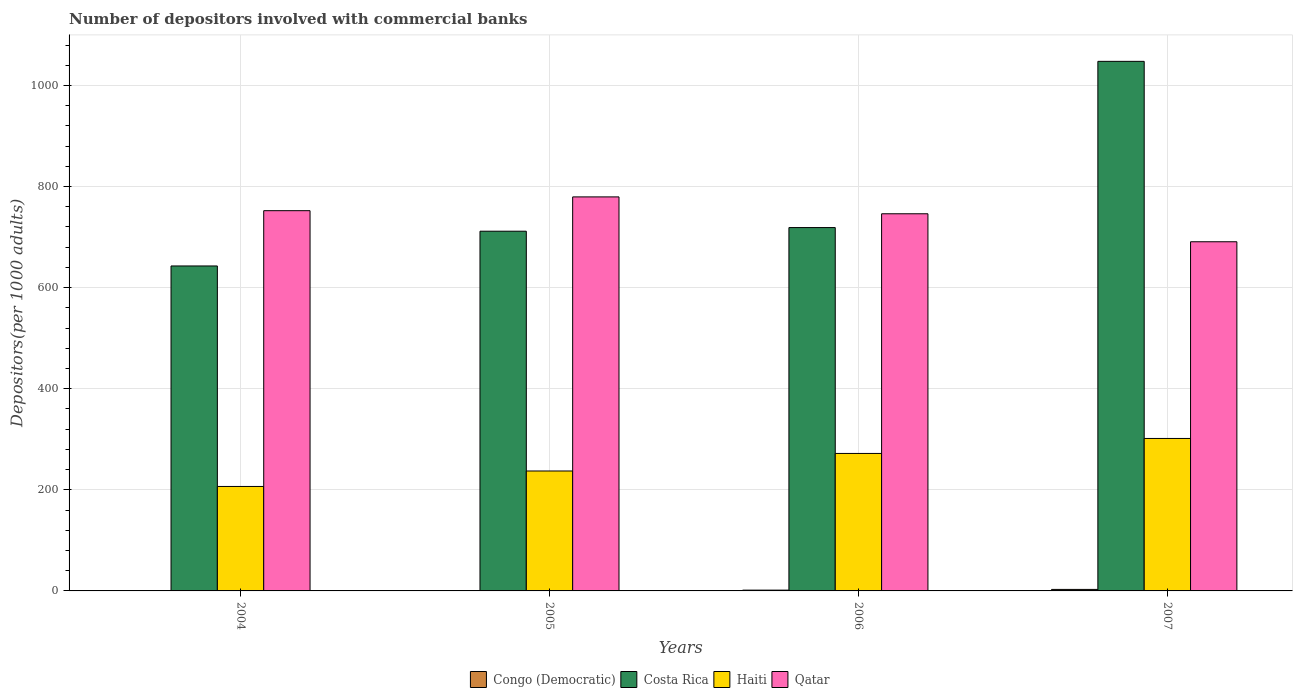How many bars are there on the 3rd tick from the left?
Offer a very short reply. 4. How many bars are there on the 3rd tick from the right?
Offer a very short reply. 4. What is the label of the 1st group of bars from the left?
Your answer should be very brief. 2004. In how many cases, is the number of bars for a given year not equal to the number of legend labels?
Keep it short and to the point. 0. What is the number of depositors involved with commercial banks in Qatar in 2005?
Your answer should be very brief. 779.56. Across all years, what is the maximum number of depositors involved with commercial banks in Qatar?
Provide a short and direct response. 779.56. Across all years, what is the minimum number of depositors involved with commercial banks in Qatar?
Offer a very short reply. 690.79. In which year was the number of depositors involved with commercial banks in Haiti minimum?
Offer a terse response. 2004. What is the total number of depositors involved with commercial banks in Haiti in the graph?
Make the answer very short. 1017.57. What is the difference between the number of depositors involved with commercial banks in Qatar in 2004 and that in 2005?
Make the answer very short. -27.27. What is the difference between the number of depositors involved with commercial banks in Congo (Democratic) in 2006 and the number of depositors involved with commercial banks in Haiti in 2004?
Ensure brevity in your answer.  -205.11. What is the average number of depositors involved with commercial banks in Costa Rica per year?
Make the answer very short. 780.3. In the year 2007, what is the difference between the number of depositors involved with commercial banks in Congo (Democratic) and number of depositors involved with commercial banks in Qatar?
Your response must be concise. -687.82. In how many years, is the number of depositors involved with commercial banks in Costa Rica greater than 200?
Keep it short and to the point. 4. What is the ratio of the number of depositors involved with commercial banks in Congo (Democratic) in 2005 to that in 2006?
Your answer should be compact. 0.51. What is the difference between the highest and the second highest number of depositors involved with commercial banks in Qatar?
Your response must be concise. 27.27. What is the difference between the highest and the lowest number of depositors involved with commercial banks in Costa Rica?
Provide a short and direct response. 404.79. In how many years, is the number of depositors involved with commercial banks in Qatar greater than the average number of depositors involved with commercial banks in Qatar taken over all years?
Offer a terse response. 3. Is the sum of the number of depositors involved with commercial banks in Congo (Democratic) in 2005 and 2007 greater than the maximum number of depositors involved with commercial banks in Qatar across all years?
Provide a succinct answer. No. Is it the case that in every year, the sum of the number of depositors involved with commercial banks in Haiti and number of depositors involved with commercial banks in Congo (Democratic) is greater than the sum of number of depositors involved with commercial banks in Qatar and number of depositors involved with commercial banks in Costa Rica?
Your response must be concise. No. What does the 3rd bar from the left in 2004 represents?
Give a very brief answer. Haiti. What does the 1st bar from the right in 2004 represents?
Make the answer very short. Qatar. How many bars are there?
Your answer should be compact. 16. What is the difference between two consecutive major ticks on the Y-axis?
Keep it short and to the point. 200. Are the values on the major ticks of Y-axis written in scientific E-notation?
Make the answer very short. No. Does the graph contain any zero values?
Provide a short and direct response. No. Where does the legend appear in the graph?
Provide a succinct answer. Bottom center. How many legend labels are there?
Ensure brevity in your answer.  4. What is the title of the graph?
Provide a succinct answer. Number of depositors involved with commercial banks. What is the label or title of the Y-axis?
Offer a terse response. Depositors(per 1000 adults). What is the Depositors(per 1000 adults) in Congo (Democratic) in 2004?
Ensure brevity in your answer.  0.48. What is the Depositors(per 1000 adults) of Costa Rica in 2004?
Offer a very short reply. 642.93. What is the Depositors(per 1000 adults) of Haiti in 2004?
Give a very brief answer. 206.67. What is the Depositors(per 1000 adults) of Qatar in 2004?
Keep it short and to the point. 752.28. What is the Depositors(per 1000 adults) of Congo (Democratic) in 2005?
Offer a very short reply. 0.8. What is the Depositors(per 1000 adults) in Costa Rica in 2005?
Your answer should be very brief. 711.68. What is the Depositors(per 1000 adults) of Haiti in 2005?
Ensure brevity in your answer.  237.27. What is the Depositors(per 1000 adults) of Qatar in 2005?
Your answer should be very brief. 779.56. What is the Depositors(per 1000 adults) of Congo (Democratic) in 2006?
Keep it short and to the point. 1.56. What is the Depositors(per 1000 adults) in Costa Rica in 2006?
Your answer should be compact. 718.87. What is the Depositors(per 1000 adults) of Haiti in 2006?
Offer a terse response. 271.98. What is the Depositors(per 1000 adults) of Qatar in 2006?
Your answer should be very brief. 746.16. What is the Depositors(per 1000 adults) in Congo (Democratic) in 2007?
Offer a terse response. 2.98. What is the Depositors(per 1000 adults) in Costa Rica in 2007?
Provide a short and direct response. 1047.71. What is the Depositors(per 1000 adults) in Haiti in 2007?
Offer a very short reply. 301.64. What is the Depositors(per 1000 adults) in Qatar in 2007?
Provide a short and direct response. 690.79. Across all years, what is the maximum Depositors(per 1000 adults) of Congo (Democratic)?
Give a very brief answer. 2.98. Across all years, what is the maximum Depositors(per 1000 adults) of Costa Rica?
Make the answer very short. 1047.71. Across all years, what is the maximum Depositors(per 1000 adults) in Haiti?
Your answer should be very brief. 301.64. Across all years, what is the maximum Depositors(per 1000 adults) in Qatar?
Give a very brief answer. 779.56. Across all years, what is the minimum Depositors(per 1000 adults) in Congo (Democratic)?
Provide a succinct answer. 0.48. Across all years, what is the minimum Depositors(per 1000 adults) in Costa Rica?
Ensure brevity in your answer.  642.93. Across all years, what is the minimum Depositors(per 1000 adults) of Haiti?
Your answer should be compact. 206.67. Across all years, what is the minimum Depositors(per 1000 adults) of Qatar?
Ensure brevity in your answer.  690.79. What is the total Depositors(per 1000 adults) in Congo (Democratic) in the graph?
Give a very brief answer. 5.83. What is the total Depositors(per 1000 adults) of Costa Rica in the graph?
Give a very brief answer. 3121.18. What is the total Depositors(per 1000 adults) of Haiti in the graph?
Ensure brevity in your answer.  1017.57. What is the total Depositors(per 1000 adults) in Qatar in the graph?
Your answer should be very brief. 2968.8. What is the difference between the Depositors(per 1000 adults) of Congo (Democratic) in 2004 and that in 2005?
Provide a succinct answer. -0.32. What is the difference between the Depositors(per 1000 adults) in Costa Rica in 2004 and that in 2005?
Your answer should be compact. -68.75. What is the difference between the Depositors(per 1000 adults) of Haiti in 2004 and that in 2005?
Provide a succinct answer. -30.6. What is the difference between the Depositors(per 1000 adults) in Qatar in 2004 and that in 2005?
Offer a terse response. -27.27. What is the difference between the Depositors(per 1000 adults) in Congo (Democratic) in 2004 and that in 2006?
Your answer should be very brief. -1.08. What is the difference between the Depositors(per 1000 adults) of Costa Rica in 2004 and that in 2006?
Keep it short and to the point. -75.94. What is the difference between the Depositors(per 1000 adults) in Haiti in 2004 and that in 2006?
Your response must be concise. -65.31. What is the difference between the Depositors(per 1000 adults) of Qatar in 2004 and that in 2006?
Offer a terse response. 6.12. What is the difference between the Depositors(per 1000 adults) in Congo (Democratic) in 2004 and that in 2007?
Offer a terse response. -2.5. What is the difference between the Depositors(per 1000 adults) of Costa Rica in 2004 and that in 2007?
Your answer should be compact. -404.79. What is the difference between the Depositors(per 1000 adults) of Haiti in 2004 and that in 2007?
Ensure brevity in your answer.  -94.97. What is the difference between the Depositors(per 1000 adults) of Qatar in 2004 and that in 2007?
Offer a very short reply. 61.49. What is the difference between the Depositors(per 1000 adults) of Congo (Democratic) in 2005 and that in 2006?
Give a very brief answer. -0.76. What is the difference between the Depositors(per 1000 adults) of Costa Rica in 2005 and that in 2006?
Your response must be concise. -7.19. What is the difference between the Depositors(per 1000 adults) of Haiti in 2005 and that in 2006?
Your answer should be very brief. -34.71. What is the difference between the Depositors(per 1000 adults) in Qatar in 2005 and that in 2006?
Offer a very short reply. 33.4. What is the difference between the Depositors(per 1000 adults) in Congo (Democratic) in 2005 and that in 2007?
Offer a very short reply. -2.18. What is the difference between the Depositors(per 1000 adults) of Costa Rica in 2005 and that in 2007?
Give a very brief answer. -336.04. What is the difference between the Depositors(per 1000 adults) of Haiti in 2005 and that in 2007?
Your answer should be compact. -64.37. What is the difference between the Depositors(per 1000 adults) in Qatar in 2005 and that in 2007?
Offer a terse response. 88.76. What is the difference between the Depositors(per 1000 adults) in Congo (Democratic) in 2006 and that in 2007?
Your response must be concise. -1.42. What is the difference between the Depositors(per 1000 adults) of Costa Rica in 2006 and that in 2007?
Your response must be concise. -328.85. What is the difference between the Depositors(per 1000 adults) of Haiti in 2006 and that in 2007?
Your response must be concise. -29.66. What is the difference between the Depositors(per 1000 adults) of Qatar in 2006 and that in 2007?
Give a very brief answer. 55.37. What is the difference between the Depositors(per 1000 adults) in Congo (Democratic) in 2004 and the Depositors(per 1000 adults) in Costa Rica in 2005?
Give a very brief answer. -711.19. What is the difference between the Depositors(per 1000 adults) of Congo (Democratic) in 2004 and the Depositors(per 1000 adults) of Haiti in 2005?
Provide a short and direct response. -236.79. What is the difference between the Depositors(per 1000 adults) of Congo (Democratic) in 2004 and the Depositors(per 1000 adults) of Qatar in 2005?
Provide a short and direct response. -779.07. What is the difference between the Depositors(per 1000 adults) of Costa Rica in 2004 and the Depositors(per 1000 adults) of Haiti in 2005?
Keep it short and to the point. 405.65. What is the difference between the Depositors(per 1000 adults) of Costa Rica in 2004 and the Depositors(per 1000 adults) of Qatar in 2005?
Give a very brief answer. -136.63. What is the difference between the Depositors(per 1000 adults) of Haiti in 2004 and the Depositors(per 1000 adults) of Qatar in 2005?
Offer a very short reply. -572.89. What is the difference between the Depositors(per 1000 adults) in Congo (Democratic) in 2004 and the Depositors(per 1000 adults) in Costa Rica in 2006?
Give a very brief answer. -718.38. What is the difference between the Depositors(per 1000 adults) of Congo (Democratic) in 2004 and the Depositors(per 1000 adults) of Haiti in 2006?
Offer a terse response. -271.5. What is the difference between the Depositors(per 1000 adults) of Congo (Democratic) in 2004 and the Depositors(per 1000 adults) of Qatar in 2006?
Your answer should be very brief. -745.68. What is the difference between the Depositors(per 1000 adults) of Costa Rica in 2004 and the Depositors(per 1000 adults) of Haiti in 2006?
Keep it short and to the point. 370.94. What is the difference between the Depositors(per 1000 adults) in Costa Rica in 2004 and the Depositors(per 1000 adults) in Qatar in 2006?
Your answer should be compact. -103.23. What is the difference between the Depositors(per 1000 adults) in Haiti in 2004 and the Depositors(per 1000 adults) in Qatar in 2006?
Your response must be concise. -539.49. What is the difference between the Depositors(per 1000 adults) of Congo (Democratic) in 2004 and the Depositors(per 1000 adults) of Costa Rica in 2007?
Provide a succinct answer. -1047.23. What is the difference between the Depositors(per 1000 adults) in Congo (Democratic) in 2004 and the Depositors(per 1000 adults) in Haiti in 2007?
Ensure brevity in your answer.  -301.16. What is the difference between the Depositors(per 1000 adults) in Congo (Democratic) in 2004 and the Depositors(per 1000 adults) in Qatar in 2007?
Ensure brevity in your answer.  -690.31. What is the difference between the Depositors(per 1000 adults) of Costa Rica in 2004 and the Depositors(per 1000 adults) of Haiti in 2007?
Your answer should be very brief. 341.28. What is the difference between the Depositors(per 1000 adults) of Costa Rica in 2004 and the Depositors(per 1000 adults) of Qatar in 2007?
Offer a very short reply. -47.87. What is the difference between the Depositors(per 1000 adults) of Haiti in 2004 and the Depositors(per 1000 adults) of Qatar in 2007?
Provide a short and direct response. -484.12. What is the difference between the Depositors(per 1000 adults) of Congo (Democratic) in 2005 and the Depositors(per 1000 adults) of Costa Rica in 2006?
Make the answer very short. -718.06. What is the difference between the Depositors(per 1000 adults) of Congo (Democratic) in 2005 and the Depositors(per 1000 adults) of Haiti in 2006?
Keep it short and to the point. -271.18. What is the difference between the Depositors(per 1000 adults) in Congo (Democratic) in 2005 and the Depositors(per 1000 adults) in Qatar in 2006?
Give a very brief answer. -745.36. What is the difference between the Depositors(per 1000 adults) of Costa Rica in 2005 and the Depositors(per 1000 adults) of Haiti in 2006?
Your response must be concise. 439.69. What is the difference between the Depositors(per 1000 adults) in Costa Rica in 2005 and the Depositors(per 1000 adults) in Qatar in 2006?
Ensure brevity in your answer.  -34.48. What is the difference between the Depositors(per 1000 adults) of Haiti in 2005 and the Depositors(per 1000 adults) of Qatar in 2006?
Provide a short and direct response. -508.89. What is the difference between the Depositors(per 1000 adults) in Congo (Democratic) in 2005 and the Depositors(per 1000 adults) in Costa Rica in 2007?
Your response must be concise. -1046.91. What is the difference between the Depositors(per 1000 adults) of Congo (Democratic) in 2005 and the Depositors(per 1000 adults) of Haiti in 2007?
Offer a terse response. -300.84. What is the difference between the Depositors(per 1000 adults) of Congo (Democratic) in 2005 and the Depositors(per 1000 adults) of Qatar in 2007?
Your response must be concise. -689.99. What is the difference between the Depositors(per 1000 adults) in Costa Rica in 2005 and the Depositors(per 1000 adults) in Haiti in 2007?
Provide a succinct answer. 410.03. What is the difference between the Depositors(per 1000 adults) of Costa Rica in 2005 and the Depositors(per 1000 adults) of Qatar in 2007?
Your response must be concise. 20.88. What is the difference between the Depositors(per 1000 adults) of Haiti in 2005 and the Depositors(per 1000 adults) of Qatar in 2007?
Your answer should be compact. -453.52. What is the difference between the Depositors(per 1000 adults) of Congo (Democratic) in 2006 and the Depositors(per 1000 adults) of Costa Rica in 2007?
Provide a succinct answer. -1046.15. What is the difference between the Depositors(per 1000 adults) in Congo (Democratic) in 2006 and the Depositors(per 1000 adults) in Haiti in 2007?
Your answer should be compact. -300.08. What is the difference between the Depositors(per 1000 adults) in Congo (Democratic) in 2006 and the Depositors(per 1000 adults) in Qatar in 2007?
Provide a succinct answer. -689.23. What is the difference between the Depositors(per 1000 adults) of Costa Rica in 2006 and the Depositors(per 1000 adults) of Haiti in 2007?
Make the answer very short. 417.22. What is the difference between the Depositors(per 1000 adults) of Costa Rica in 2006 and the Depositors(per 1000 adults) of Qatar in 2007?
Give a very brief answer. 28.07. What is the difference between the Depositors(per 1000 adults) of Haiti in 2006 and the Depositors(per 1000 adults) of Qatar in 2007?
Keep it short and to the point. -418.81. What is the average Depositors(per 1000 adults) in Congo (Democratic) per year?
Your answer should be compact. 1.46. What is the average Depositors(per 1000 adults) of Costa Rica per year?
Your response must be concise. 780.3. What is the average Depositors(per 1000 adults) in Haiti per year?
Provide a succinct answer. 254.39. What is the average Depositors(per 1000 adults) of Qatar per year?
Your answer should be compact. 742.2. In the year 2004, what is the difference between the Depositors(per 1000 adults) of Congo (Democratic) and Depositors(per 1000 adults) of Costa Rica?
Keep it short and to the point. -642.44. In the year 2004, what is the difference between the Depositors(per 1000 adults) of Congo (Democratic) and Depositors(per 1000 adults) of Haiti?
Provide a short and direct response. -206.19. In the year 2004, what is the difference between the Depositors(per 1000 adults) of Congo (Democratic) and Depositors(per 1000 adults) of Qatar?
Provide a succinct answer. -751.8. In the year 2004, what is the difference between the Depositors(per 1000 adults) in Costa Rica and Depositors(per 1000 adults) in Haiti?
Offer a very short reply. 436.26. In the year 2004, what is the difference between the Depositors(per 1000 adults) of Costa Rica and Depositors(per 1000 adults) of Qatar?
Keep it short and to the point. -109.36. In the year 2004, what is the difference between the Depositors(per 1000 adults) in Haiti and Depositors(per 1000 adults) in Qatar?
Offer a very short reply. -545.61. In the year 2005, what is the difference between the Depositors(per 1000 adults) of Congo (Democratic) and Depositors(per 1000 adults) of Costa Rica?
Make the answer very short. -710.87. In the year 2005, what is the difference between the Depositors(per 1000 adults) in Congo (Democratic) and Depositors(per 1000 adults) in Haiti?
Keep it short and to the point. -236.47. In the year 2005, what is the difference between the Depositors(per 1000 adults) in Congo (Democratic) and Depositors(per 1000 adults) in Qatar?
Your answer should be compact. -778.76. In the year 2005, what is the difference between the Depositors(per 1000 adults) in Costa Rica and Depositors(per 1000 adults) in Haiti?
Make the answer very short. 474.4. In the year 2005, what is the difference between the Depositors(per 1000 adults) of Costa Rica and Depositors(per 1000 adults) of Qatar?
Your response must be concise. -67.88. In the year 2005, what is the difference between the Depositors(per 1000 adults) in Haiti and Depositors(per 1000 adults) in Qatar?
Your answer should be very brief. -542.28. In the year 2006, what is the difference between the Depositors(per 1000 adults) in Congo (Democratic) and Depositors(per 1000 adults) in Costa Rica?
Offer a very short reply. -717.3. In the year 2006, what is the difference between the Depositors(per 1000 adults) of Congo (Democratic) and Depositors(per 1000 adults) of Haiti?
Make the answer very short. -270.42. In the year 2006, what is the difference between the Depositors(per 1000 adults) of Congo (Democratic) and Depositors(per 1000 adults) of Qatar?
Your answer should be compact. -744.6. In the year 2006, what is the difference between the Depositors(per 1000 adults) in Costa Rica and Depositors(per 1000 adults) in Haiti?
Give a very brief answer. 446.88. In the year 2006, what is the difference between the Depositors(per 1000 adults) of Costa Rica and Depositors(per 1000 adults) of Qatar?
Provide a short and direct response. -27.3. In the year 2006, what is the difference between the Depositors(per 1000 adults) in Haiti and Depositors(per 1000 adults) in Qatar?
Your answer should be compact. -474.18. In the year 2007, what is the difference between the Depositors(per 1000 adults) of Congo (Democratic) and Depositors(per 1000 adults) of Costa Rica?
Keep it short and to the point. -1044.73. In the year 2007, what is the difference between the Depositors(per 1000 adults) in Congo (Democratic) and Depositors(per 1000 adults) in Haiti?
Your answer should be very brief. -298.66. In the year 2007, what is the difference between the Depositors(per 1000 adults) in Congo (Democratic) and Depositors(per 1000 adults) in Qatar?
Offer a terse response. -687.82. In the year 2007, what is the difference between the Depositors(per 1000 adults) of Costa Rica and Depositors(per 1000 adults) of Haiti?
Keep it short and to the point. 746.07. In the year 2007, what is the difference between the Depositors(per 1000 adults) of Costa Rica and Depositors(per 1000 adults) of Qatar?
Your response must be concise. 356.92. In the year 2007, what is the difference between the Depositors(per 1000 adults) in Haiti and Depositors(per 1000 adults) in Qatar?
Keep it short and to the point. -389.15. What is the ratio of the Depositors(per 1000 adults) in Congo (Democratic) in 2004 to that in 2005?
Make the answer very short. 0.6. What is the ratio of the Depositors(per 1000 adults) of Costa Rica in 2004 to that in 2005?
Your answer should be compact. 0.9. What is the ratio of the Depositors(per 1000 adults) in Haiti in 2004 to that in 2005?
Give a very brief answer. 0.87. What is the ratio of the Depositors(per 1000 adults) of Qatar in 2004 to that in 2005?
Provide a succinct answer. 0.96. What is the ratio of the Depositors(per 1000 adults) in Congo (Democratic) in 2004 to that in 2006?
Your answer should be very brief. 0.31. What is the ratio of the Depositors(per 1000 adults) of Costa Rica in 2004 to that in 2006?
Offer a very short reply. 0.89. What is the ratio of the Depositors(per 1000 adults) in Haiti in 2004 to that in 2006?
Your response must be concise. 0.76. What is the ratio of the Depositors(per 1000 adults) in Qatar in 2004 to that in 2006?
Your response must be concise. 1.01. What is the ratio of the Depositors(per 1000 adults) in Congo (Democratic) in 2004 to that in 2007?
Your answer should be compact. 0.16. What is the ratio of the Depositors(per 1000 adults) of Costa Rica in 2004 to that in 2007?
Make the answer very short. 0.61. What is the ratio of the Depositors(per 1000 adults) in Haiti in 2004 to that in 2007?
Your answer should be very brief. 0.69. What is the ratio of the Depositors(per 1000 adults) of Qatar in 2004 to that in 2007?
Give a very brief answer. 1.09. What is the ratio of the Depositors(per 1000 adults) of Congo (Democratic) in 2005 to that in 2006?
Give a very brief answer. 0.51. What is the ratio of the Depositors(per 1000 adults) of Haiti in 2005 to that in 2006?
Give a very brief answer. 0.87. What is the ratio of the Depositors(per 1000 adults) in Qatar in 2005 to that in 2006?
Ensure brevity in your answer.  1.04. What is the ratio of the Depositors(per 1000 adults) of Congo (Democratic) in 2005 to that in 2007?
Your response must be concise. 0.27. What is the ratio of the Depositors(per 1000 adults) in Costa Rica in 2005 to that in 2007?
Offer a very short reply. 0.68. What is the ratio of the Depositors(per 1000 adults) in Haiti in 2005 to that in 2007?
Provide a short and direct response. 0.79. What is the ratio of the Depositors(per 1000 adults) in Qatar in 2005 to that in 2007?
Your answer should be very brief. 1.13. What is the ratio of the Depositors(per 1000 adults) of Congo (Democratic) in 2006 to that in 2007?
Keep it short and to the point. 0.52. What is the ratio of the Depositors(per 1000 adults) of Costa Rica in 2006 to that in 2007?
Your answer should be very brief. 0.69. What is the ratio of the Depositors(per 1000 adults) in Haiti in 2006 to that in 2007?
Offer a terse response. 0.9. What is the ratio of the Depositors(per 1000 adults) in Qatar in 2006 to that in 2007?
Make the answer very short. 1.08. What is the difference between the highest and the second highest Depositors(per 1000 adults) of Congo (Democratic)?
Offer a very short reply. 1.42. What is the difference between the highest and the second highest Depositors(per 1000 adults) in Costa Rica?
Make the answer very short. 328.85. What is the difference between the highest and the second highest Depositors(per 1000 adults) in Haiti?
Keep it short and to the point. 29.66. What is the difference between the highest and the second highest Depositors(per 1000 adults) in Qatar?
Provide a succinct answer. 27.27. What is the difference between the highest and the lowest Depositors(per 1000 adults) in Congo (Democratic)?
Keep it short and to the point. 2.5. What is the difference between the highest and the lowest Depositors(per 1000 adults) in Costa Rica?
Provide a short and direct response. 404.79. What is the difference between the highest and the lowest Depositors(per 1000 adults) of Haiti?
Keep it short and to the point. 94.97. What is the difference between the highest and the lowest Depositors(per 1000 adults) of Qatar?
Your answer should be compact. 88.76. 